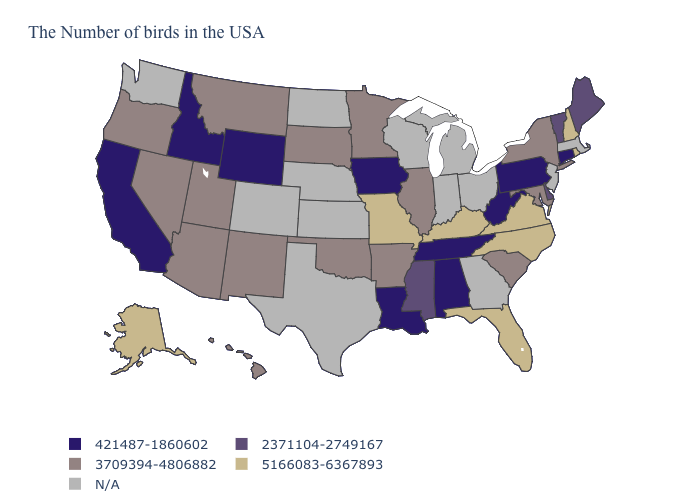What is the highest value in the South ?
Answer briefly. 5166083-6367893. What is the value of Kansas?
Short answer required. N/A. What is the value of Michigan?
Be succinct. N/A. Does the map have missing data?
Short answer required. Yes. Among the states that border New York , does Vermont have the lowest value?
Give a very brief answer. No. What is the value of Delaware?
Be succinct. 2371104-2749167. Which states have the lowest value in the USA?
Concise answer only. Connecticut, Pennsylvania, West Virginia, Alabama, Tennessee, Louisiana, Iowa, Wyoming, Idaho, California. Name the states that have a value in the range N/A?
Give a very brief answer. Massachusetts, New Jersey, Ohio, Georgia, Michigan, Indiana, Wisconsin, Kansas, Nebraska, Texas, North Dakota, Colorado, Washington. Name the states that have a value in the range 3709394-4806882?
Give a very brief answer. New York, Maryland, South Carolina, Illinois, Arkansas, Minnesota, Oklahoma, South Dakota, New Mexico, Utah, Montana, Arizona, Nevada, Oregon, Hawaii. Name the states that have a value in the range 421487-1860602?
Quick response, please. Connecticut, Pennsylvania, West Virginia, Alabama, Tennessee, Louisiana, Iowa, Wyoming, Idaho, California. What is the value of Michigan?
Give a very brief answer. N/A. Name the states that have a value in the range 421487-1860602?
Write a very short answer. Connecticut, Pennsylvania, West Virginia, Alabama, Tennessee, Louisiana, Iowa, Wyoming, Idaho, California. Among the states that border Virginia , does Tennessee have the highest value?
Short answer required. No. Name the states that have a value in the range 421487-1860602?
Concise answer only. Connecticut, Pennsylvania, West Virginia, Alabama, Tennessee, Louisiana, Iowa, Wyoming, Idaho, California. Name the states that have a value in the range 421487-1860602?
Write a very short answer. Connecticut, Pennsylvania, West Virginia, Alabama, Tennessee, Louisiana, Iowa, Wyoming, Idaho, California. 